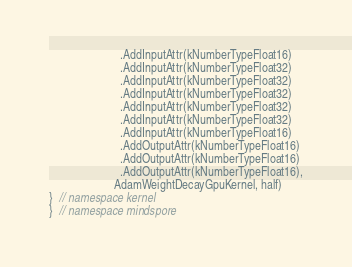Convert code to text. <code><loc_0><loc_0><loc_500><loc_500><_C++_>                        .AddInputAttr(kNumberTypeFloat16)
                        .AddInputAttr(kNumberTypeFloat32)
                        .AddInputAttr(kNumberTypeFloat32)
                        .AddInputAttr(kNumberTypeFloat32)
                        .AddInputAttr(kNumberTypeFloat32)
                        .AddInputAttr(kNumberTypeFloat32)
                        .AddInputAttr(kNumberTypeFloat16)
                        .AddOutputAttr(kNumberTypeFloat16)
                        .AddOutputAttr(kNumberTypeFloat16)
                        .AddOutputAttr(kNumberTypeFloat16),
                      AdamWeightDecayGpuKernel, half)
}  // namespace kernel
}  // namespace mindspore
</code> 